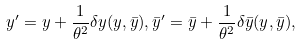Convert formula to latex. <formula><loc_0><loc_0><loc_500><loc_500>y ^ { \prime } = y + \frac { 1 } { \theta ^ { 2 } } \delta y ( y , \bar { y } ) , \bar { y } ^ { \prime } = \bar { y } + \frac { 1 } { \theta ^ { 2 } } \delta \bar { y } ( y , \bar { y } ) ,</formula> 